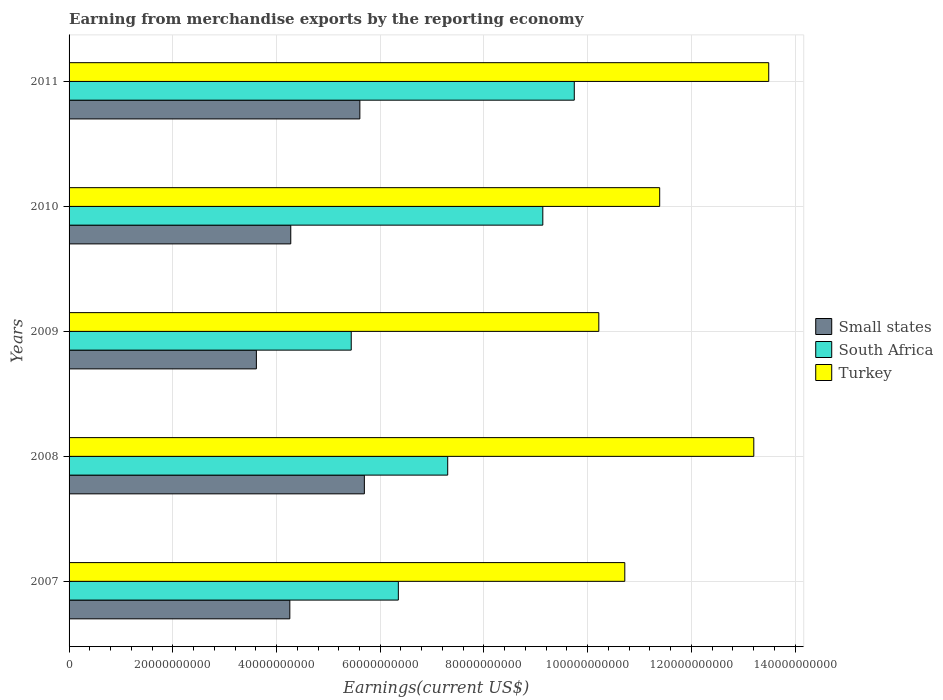How many different coloured bars are there?
Your response must be concise. 3. Are the number of bars on each tick of the Y-axis equal?
Your response must be concise. Yes. How many bars are there on the 1st tick from the top?
Your answer should be compact. 3. What is the amount earned from merchandise exports in South Africa in 2011?
Ensure brevity in your answer.  9.74e+1. Across all years, what is the maximum amount earned from merchandise exports in South Africa?
Offer a terse response. 9.74e+1. Across all years, what is the minimum amount earned from merchandise exports in Small states?
Your answer should be very brief. 3.61e+1. In which year was the amount earned from merchandise exports in South Africa maximum?
Your answer should be very brief. 2011. In which year was the amount earned from merchandise exports in Small states minimum?
Your answer should be compact. 2009. What is the total amount earned from merchandise exports in South Africa in the graph?
Your response must be concise. 3.80e+11. What is the difference between the amount earned from merchandise exports in Turkey in 2008 and that in 2011?
Offer a terse response. -2.88e+09. What is the difference between the amount earned from merchandise exports in Turkey in 2010 and the amount earned from merchandise exports in South Africa in 2009?
Provide a short and direct response. 5.95e+1. What is the average amount earned from merchandise exports in South Africa per year?
Provide a succinct answer. 7.59e+1. In the year 2007, what is the difference between the amount earned from merchandise exports in South Africa and amount earned from merchandise exports in Turkey?
Ensure brevity in your answer.  -4.37e+1. In how many years, is the amount earned from merchandise exports in South Africa greater than 72000000000 US$?
Your answer should be very brief. 3. What is the ratio of the amount earned from merchandise exports in South Africa in 2008 to that in 2010?
Make the answer very short. 0.8. What is the difference between the highest and the second highest amount earned from merchandise exports in Turkey?
Make the answer very short. 2.88e+09. What is the difference between the highest and the lowest amount earned from merchandise exports in Turkey?
Provide a succinct answer. 3.28e+1. Is the sum of the amount earned from merchandise exports in Turkey in 2009 and 2011 greater than the maximum amount earned from merchandise exports in Small states across all years?
Keep it short and to the point. Yes. What does the 2nd bar from the top in 2007 represents?
Offer a very short reply. South Africa. What does the 3rd bar from the bottom in 2011 represents?
Your response must be concise. Turkey. How many bars are there?
Offer a terse response. 15. How many legend labels are there?
Provide a succinct answer. 3. How are the legend labels stacked?
Your answer should be very brief. Vertical. What is the title of the graph?
Make the answer very short. Earning from merchandise exports by the reporting economy. Does "Poland" appear as one of the legend labels in the graph?
Keep it short and to the point. No. What is the label or title of the X-axis?
Keep it short and to the point. Earnings(current US$). What is the Earnings(current US$) of Small states in 2007?
Provide a short and direct response. 4.26e+1. What is the Earnings(current US$) of South Africa in 2007?
Your response must be concise. 6.35e+1. What is the Earnings(current US$) of Turkey in 2007?
Give a very brief answer. 1.07e+11. What is the Earnings(current US$) of Small states in 2008?
Your response must be concise. 5.69e+1. What is the Earnings(current US$) of South Africa in 2008?
Your answer should be compact. 7.30e+1. What is the Earnings(current US$) of Turkey in 2008?
Offer a very short reply. 1.32e+11. What is the Earnings(current US$) in Small states in 2009?
Your answer should be very brief. 3.61e+1. What is the Earnings(current US$) in South Africa in 2009?
Offer a terse response. 5.44e+1. What is the Earnings(current US$) of Turkey in 2009?
Make the answer very short. 1.02e+11. What is the Earnings(current US$) in Small states in 2010?
Keep it short and to the point. 4.27e+1. What is the Earnings(current US$) in South Africa in 2010?
Provide a short and direct response. 9.13e+1. What is the Earnings(current US$) in Turkey in 2010?
Keep it short and to the point. 1.14e+11. What is the Earnings(current US$) of Small states in 2011?
Your answer should be very brief. 5.61e+1. What is the Earnings(current US$) in South Africa in 2011?
Give a very brief answer. 9.74e+1. What is the Earnings(current US$) of Turkey in 2011?
Make the answer very short. 1.35e+11. Across all years, what is the maximum Earnings(current US$) of Small states?
Keep it short and to the point. 5.69e+1. Across all years, what is the maximum Earnings(current US$) of South Africa?
Keep it short and to the point. 9.74e+1. Across all years, what is the maximum Earnings(current US$) in Turkey?
Provide a short and direct response. 1.35e+11. Across all years, what is the minimum Earnings(current US$) in Small states?
Give a very brief answer. 3.61e+1. Across all years, what is the minimum Earnings(current US$) in South Africa?
Make the answer very short. 5.44e+1. Across all years, what is the minimum Earnings(current US$) of Turkey?
Keep it short and to the point. 1.02e+11. What is the total Earnings(current US$) in Small states in the graph?
Your response must be concise. 2.34e+11. What is the total Earnings(current US$) in South Africa in the graph?
Give a very brief answer. 3.80e+11. What is the total Earnings(current US$) of Turkey in the graph?
Keep it short and to the point. 5.90e+11. What is the difference between the Earnings(current US$) of Small states in 2007 and that in 2008?
Give a very brief answer. -1.44e+1. What is the difference between the Earnings(current US$) of South Africa in 2007 and that in 2008?
Your answer should be compact. -9.52e+09. What is the difference between the Earnings(current US$) in Turkey in 2007 and that in 2008?
Ensure brevity in your answer.  -2.49e+1. What is the difference between the Earnings(current US$) in Small states in 2007 and that in 2009?
Provide a short and direct response. 6.45e+09. What is the difference between the Earnings(current US$) of South Africa in 2007 and that in 2009?
Ensure brevity in your answer.  9.08e+09. What is the difference between the Earnings(current US$) of Turkey in 2007 and that in 2009?
Provide a short and direct response. 5.01e+09. What is the difference between the Earnings(current US$) of Small states in 2007 and that in 2010?
Your answer should be compact. -1.81e+08. What is the difference between the Earnings(current US$) of South Africa in 2007 and that in 2010?
Your answer should be very brief. -2.79e+1. What is the difference between the Earnings(current US$) in Turkey in 2007 and that in 2010?
Your response must be concise. -6.73e+09. What is the difference between the Earnings(current US$) in Small states in 2007 and that in 2011?
Offer a terse response. -1.35e+1. What is the difference between the Earnings(current US$) of South Africa in 2007 and that in 2011?
Your answer should be compact. -3.39e+1. What is the difference between the Earnings(current US$) of Turkey in 2007 and that in 2011?
Give a very brief answer. -2.78e+1. What is the difference between the Earnings(current US$) of Small states in 2008 and that in 2009?
Keep it short and to the point. 2.08e+1. What is the difference between the Earnings(current US$) of South Africa in 2008 and that in 2009?
Offer a terse response. 1.86e+1. What is the difference between the Earnings(current US$) of Turkey in 2008 and that in 2009?
Offer a very short reply. 2.99e+1. What is the difference between the Earnings(current US$) in Small states in 2008 and that in 2010?
Your answer should be very brief. 1.42e+1. What is the difference between the Earnings(current US$) in South Africa in 2008 and that in 2010?
Make the answer very short. -1.83e+1. What is the difference between the Earnings(current US$) in Turkey in 2008 and that in 2010?
Keep it short and to the point. 1.81e+1. What is the difference between the Earnings(current US$) in Small states in 2008 and that in 2011?
Offer a very short reply. 8.69e+08. What is the difference between the Earnings(current US$) of South Africa in 2008 and that in 2011?
Offer a very short reply. -2.44e+1. What is the difference between the Earnings(current US$) in Turkey in 2008 and that in 2011?
Your answer should be compact. -2.88e+09. What is the difference between the Earnings(current US$) in Small states in 2009 and that in 2010?
Your answer should be very brief. -6.63e+09. What is the difference between the Earnings(current US$) in South Africa in 2009 and that in 2010?
Ensure brevity in your answer.  -3.69e+1. What is the difference between the Earnings(current US$) in Turkey in 2009 and that in 2010?
Your response must be concise. -1.17e+1. What is the difference between the Earnings(current US$) of Small states in 2009 and that in 2011?
Offer a very short reply. -2.00e+1. What is the difference between the Earnings(current US$) of South Africa in 2009 and that in 2011?
Ensure brevity in your answer.  -4.30e+1. What is the difference between the Earnings(current US$) of Turkey in 2009 and that in 2011?
Provide a succinct answer. -3.28e+1. What is the difference between the Earnings(current US$) of Small states in 2010 and that in 2011?
Your answer should be compact. -1.33e+1. What is the difference between the Earnings(current US$) in South Africa in 2010 and that in 2011?
Offer a terse response. -6.07e+09. What is the difference between the Earnings(current US$) of Turkey in 2010 and that in 2011?
Offer a terse response. -2.10e+1. What is the difference between the Earnings(current US$) in Small states in 2007 and the Earnings(current US$) in South Africa in 2008?
Your answer should be compact. -3.04e+1. What is the difference between the Earnings(current US$) of Small states in 2007 and the Earnings(current US$) of Turkey in 2008?
Keep it short and to the point. -8.95e+1. What is the difference between the Earnings(current US$) of South Africa in 2007 and the Earnings(current US$) of Turkey in 2008?
Your response must be concise. -6.85e+1. What is the difference between the Earnings(current US$) of Small states in 2007 and the Earnings(current US$) of South Africa in 2009?
Your answer should be very brief. -1.18e+1. What is the difference between the Earnings(current US$) of Small states in 2007 and the Earnings(current US$) of Turkey in 2009?
Your answer should be compact. -5.96e+1. What is the difference between the Earnings(current US$) in South Africa in 2007 and the Earnings(current US$) in Turkey in 2009?
Provide a short and direct response. -3.87e+1. What is the difference between the Earnings(current US$) of Small states in 2007 and the Earnings(current US$) of South Africa in 2010?
Offer a terse response. -4.88e+1. What is the difference between the Earnings(current US$) of Small states in 2007 and the Earnings(current US$) of Turkey in 2010?
Ensure brevity in your answer.  -7.13e+1. What is the difference between the Earnings(current US$) in South Africa in 2007 and the Earnings(current US$) in Turkey in 2010?
Ensure brevity in your answer.  -5.04e+1. What is the difference between the Earnings(current US$) of Small states in 2007 and the Earnings(current US$) of South Africa in 2011?
Keep it short and to the point. -5.48e+1. What is the difference between the Earnings(current US$) in Small states in 2007 and the Earnings(current US$) in Turkey in 2011?
Ensure brevity in your answer.  -9.23e+1. What is the difference between the Earnings(current US$) in South Africa in 2007 and the Earnings(current US$) in Turkey in 2011?
Provide a succinct answer. -7.14e+1. What is the difference between the Earnings(current US$) of Small states in 2008 and the Earnings(current US$) of South Africa in 2009?
Provide a short and direct response. 2.53e+09. What is the difference between the Earnings(current US$) in Small states in 2008 and the Earnings(current US$) in Turkey in 2009?
Give a very brief answer. -4.52e+1. What is the difference between the Earnings(current US$) in South Africa in 2008 and the Earnings(current US$) in Turkey in 2009?
Keep it short and to the point. -2.91e+1. What is the difference between the Earnings(current US$) in Small states in 2008 and the Earnings(current US$) in South Africa in 2010?
Keep it short and to the point. -3.44e+1. What is the difference between the Earnings(current US$) in Small states in 2008 and the Earnings(current US$) in Turkey in 2010?
Offer a very short reply. -5.69e+1. What is the difference between the Earnings(current US$) in South Africa in 2008 and the Earnings(current US$) in Turkey in 2010?
Ensure brevity in your answer.  -4.09e+1. What is the difference between the Earnings(current US$) of Small states in 2008 and the Earnings(current US$) of South Africa in 2011?
Offer a terse response. -4.05e+1. What is the difference between the Earnings(current US$) of Small states in 2008 and the Earnings(current US$) of Turkey in 2011?
Provide a short and direct response. -7.80e+1. What is the difference between the Earnings(current US$) of South Africa in 2008 and the Earnings(current US$) of Turkey in 2011?
Offer a terse response. -6.19e+1. What is the difference between the Earnings(current US$) of Small states in 2009 and the Earnings(current US$) of South Africa in 2010?
Provide a short and direct response. -5.52e+1. What is the difference between the Earnings(current US$) of Small states in 2009 and the Earnings(current US$) of Turkey in 2010?
Offer a very short reply. -7.78e+1. What is the difference between the Earnings(current US$) in South Africa in 2009 and the Earnings(current US$) in Turkey in 2010?
Provide a short and direct response. -5.95e+1. What is the difference between the Earnings(current US$) in Small states in 2009 and the Earnings(current US$) in South Africa in 2011?
Offer a terse response. -6.13e+1. What is the difference between the Earnings(current US$) in Small states in 2009 and the Earnings(current US$) in Turkey in 2011?
Give a very brief answer. -9.88e+1. What is the difference between the Earnings(current US$) in South Africa in 2009 and the Earnings(current US$) in Turkey in 2011?
Your answer should be very brief. -8.05e+1. What is the difference between the Earnings(current US$) in Small states in 2010 and the Earnings(current US$) in South Africa in 2011?
Keep it short and to the point. -5.47e+1. What is the difference between the Earnings(current US$) in Small states in 2010 and the Earnings(current US$) in Turkey in 2011?
Make the answer very short. -9.22e+1. What is the difference between the Earnings(current US$) of South Africa in 2010 and the Earnings(current US$) of Turkey in 2011?
Ensure brevity in your answer.  -4.36e+1. What is the average Earnings(current US$) in Small states per year?
Your response must be concise. 4.69e+1. What is the average Earnings(current US$) of South Africa per year?
Offer a terse response. 7.59e+1. What is the average Earnings(current US$) in Turkey per year?
Keep it short and to the point. 1.18e+11. In the year 2007, what is the difference between the Earnings(current US$) of Small states and Earnings(current US$) of South Africa?
Your answer should be compact. -2.09e+1. In the year 2007, what is the difference between the Earnings(current US$) of Small states and Earnings(current US$) of Turkey?
Give a very brief answer. -6.46e+1. In the year 2007, what is the difference between the Earnings(current US$) in South Africa and Earnings(current US$) in Turkey?
Ensure brevity in your answer.  -4.37e+1. In the year 2008, what is the difference between the Earnings(current US$) of Small states and Earnings(current US$) of South Africa?
Provide a succinct answer. -1.61e+1. In the year 2008, what is the difference between the Earnings(current US$) in Small states and Earnings(current US$) in Turkey?
Your answer should be very brief. -7.51e+1. In the year 2008, what is the difference between the Earnings(current US$) in South Africa and Earnings(current US$) in Turkey?
Provide a succinct answer. -5.90e+1. In the year 2009, what is the difference between the Earnings(current US$) in Small states and Earnings(current US$) in South Africa?
Offer a very short reply. -1.83e+1. In the year 2009, what is the difference between the Earnings(current US$) of Small states and Earnings(current US$) of Turkey?
Provide a succinct answer. -6.60e+1. In the year 2009, what is the difference between the Earnings(current US$) in South Africa and Earnings(current US$) in Turkey?
Your answer should be very brief. -4.77e+1. In the year 2010, what is the difference between the Earnings(current US$) of Small states and Earnings(current US$) of South Africa?
Keep it short and to the point. -4.86e+1. In the year 2010, what is the difference between the Earnings(current US$) of Small states and Earnings(current US$) of Turkey?
Your answer should be compact. -7.11e+1. In the year 2010, what is the difference between the Earnings(current US$) in South Africa and Earnings(current US$) in Turkey?
Offer a terse response. -2.25e+1. In the year 2011, what is the difference between the Earnings(current US$) of Small states and Earnings(current US$) of South Africa?
Your response must be concise. -4.13e+1. In the year 2011, what is the difference between the Earnings(current US$) of Small states and Earnings(current US$) of Turkey?
Ensure brevity in your answer.  -7.88e+1. In the year 2011, what is the difference between the Earnings(current US$) in South Africa and Earnings(current US$) in Turkey?
Provide a succinct answer. -3.75e+1. What is the ratio of the Earnings(current US$) of Small states in 2007 to that in 2008?
Your response must be concise. 0.75. What is the ratio of the Earnings(current US$) in South Africa in 2007 to that in 2008?
Your answer should be very brief. 0.87. What is the ratio of the Earnings(current US$) of Turkey in 2007 to that in 2008?
Keep it short and to the point. 0.81. What is the ratio of the Earnings(current US$) in Small states in 2007 to that in 2009?
Offer a terse response. 1.18. What is the ratio of the Earnings(current US$) of South Africa in 2007 to that in 2009?
Ensure brevity in your answer.  1.17. What is the ratio of the Earnings(current US$) in Turkey in 2007 to that in 2009?
Your answer should be compact. 1.05. What is the ratio of the Earnings(current US$) in Small states in 2007 to that in 2010?
Keep it short and to the point. 1. What is the ratio of the Earnings(current US$) of South Africa in 2007 to that in 2010?
Ensure brevity in your answer.  0.69. What is the ratio of the Earnings(current US$) of Turkey in 2007 to that in 2010?
Make the answer very short. 0.94. What is the ratio of the Earnings(current US$) in Small states in 2007 to that in 2011?
Offer a terse response. 0.76. What is the ratio of the Earnings(current US$) in South Africa in 2007 to that in 2011?
Your response must be concise. 0.65. What is the ratio of the Earnings(current US$) in Turkey in 2007 to that in 2011?
Your answer should be compact. 0.79. What is the ratio of the Earnings(current US$) in Small states in 2008 to that in 2009?
Offer a very short reply. 1.58. What is the ratio of the Earnings(current US$) in South Africa in 2008 to that in 2009?
Offer a terse response. 1.34. What is the ratio of the Earnings(current US$) in Turkey in 2008 to that in 2009?
Your response must be concise. 1.29. What is the ratio of the Earnings(current US$) in Small states in 2008 to that in 2010?
Your response must be concise. 1.33. What is the ratio of the Earnings(current US$) in South Africa in 2008 to that in 2010?
Provide a short and direct response. 0.8. What is the ratio of the Earnings(current US$) in Turkey in 2008 to that in 2010?
Give a very brief answer. 1.16. What is the ratio of the Earnings(current US$) in Small states in 2008 to that in 2011?
Your answer should be very brief. 1.02. What is the ratio of the Earnings(current US$) of South Africa in 2008 to that in 2011?
Offer a very short reply. 0.75. What is the ratio of the Earnings(current US$) in Turkey in 2008 to that in 2011?
Your answer should be compact. 0.98. What is the ratio of the Earnings(current US$) of Small states in 2009 to that in 2010?
Offer a terse response. 0.84. What is the ratio of the Earnings(current US$) in South Africa in 2009 to that in 2010?
Ensure brevity in your answer.  0.6. What is the ratio of the Earnings(current US$) of Turkey in 2009 to that in 2010?
Offer a terse response. 0.9. What is the ratio of the Earnings(current US$) in Small states in 2009 to that in 2011?
Provide a succinct answer. 0.64. What is the ratio of the Earnings(current US$) of South Africa in 2009 to that in 2011?
Keep it short and to the point. 0.56. What is the ratio of the Earnings(current US$) of Turkey in 2009 to that in 2011?
Keep it short and to the point. 0.76. What is the ratio of the Earnings(current US$) of Small states in 2010 to that in 2011?
Make the answer very short. 0.76. What is the ratio of the Earnings(current US$) of South Africa in 2010 to that in 2011?
Your answer should be compact. 0.94. What is the ratio of the Earnings(current US$) of Turkey in 2010 to that in 2011?
Offer a very short reply. 0.84. What is the difference between the highest and the second highest Earnings(current US$) of Small states?
Give a very brief answer. 8.69e+08. What is the difference between the highest and the second highest Earnings(current US$) of South Africa?
Your answer should be very brief. 6.07e+09. What is the difference between the highest and the second highest Earnings(current US$) in Turkey?
Give a very brief answer. 2.88e+09. What is the difference between the highest and the lowest Earnings(current US$) in Small states?
Your answer should be compact. 2.08e+1. What is the difference between the highest and the lowest Earnings(current US$) in South Africa?
Ensure brevity in your answer.  4.30e+1. What is the difference between the highest and the lowest Earnings(current US$) of Turkey?
Ensure brevity in your answer.  3.28e+1. 